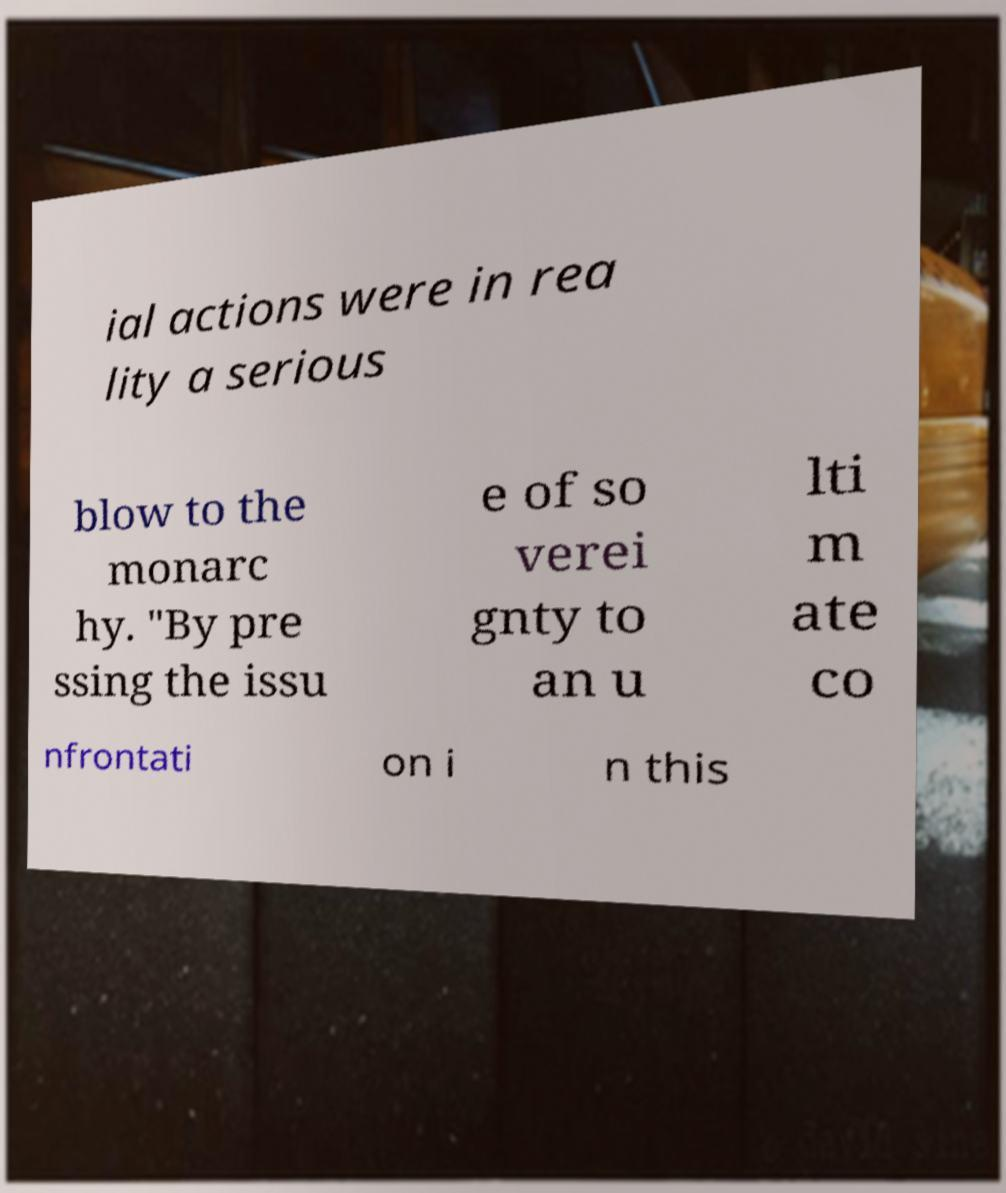Can you read and provide the text displayed in the image?This photo seems to have some interesting text. Can you extract and type it out for me? ial actions were in rea lity a serious blow to the monarc hy. "By pre ssing the issu e of so verei gnty to an u lti m ate co nfrontati on i n this 